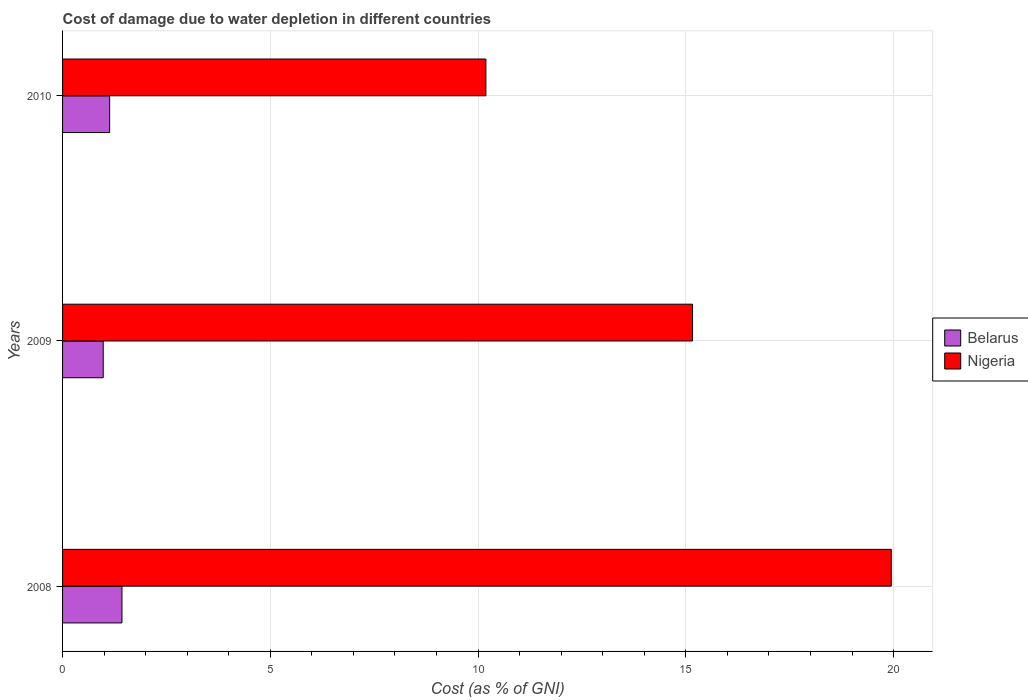How many different coloured bars are there?
Offer a terse response. 2. Are the number of bars on each tick of the Y-axis equal?
Your answer should be compact. Yes. How many bars are there on the 2nd tick from the bottom?
Provide a short and direct response. 2. In how many cases, is the number of bars for a given year not equal to the number of legend labels?
Your response must be concise. 0. What is the cost of damage caused due to water depletion in Nigeria in 2008?
Provide a succinct answer. 19.94. Across all years, what is the maximum cost of damage caused due to water depletion in Nigeria?
Give a very brief answer. 19.94. Across all years, what is the minimum cost of damage caused due to water depletion in Belarus?
Your answer should be compact. 0.98. In which year was the cost of damage caused due to water depletion in Belarus maximum?
Provide a short and direct response. 2008. What is the total cost of damage caused due to water depletion in Belarus in the graph?
Your answer should be compact. 3.54. What is the difference between the cost of damage caused due to water depletion in Nigeria in 2009 and that in 2010?
Your answer should be very brief. 4.97. What is the difference between the cost of damage caused due to water depletion in Nigeria in 2010 and the cost of damage caused due to water depletion in Belarus in 2008?
Ensure brevity in your answer.  8.76. What is the average cost of damage caused due to water depletion in Belarus per year?
Offer a terse response. 1.18. In the year 2009, what is the difference between the cost of damage caused due to water depletion in Nigeria and cost of damage caused due to water depletion in Belarus?
Your response must be concise. 14.18. What is the ratio of the cost of damage caused due to water depletion in Belarus in 2009 to that in 2010?
Your response must be concise. 0.86. What is the difference between the highest and the second highest cost of damage caused due to water depletion in Nigeria?
Give a very brief answer. 4.78. What is the difference between the highest and the lowest cost of damage caused due to water depletion in Nigeria?
Provide a succinct answer. 9.76. What does the 2nd bar from the top in 2009 represents?
Keep it short and to the point. Belarus. What does the 2nd bar from the bottom in 2008 represents?
Ensure brevity in your answer.  Nigeria. How many bars are there?
Offer a terse response. 6. Are all the bars in the graph horizontal?
Your answer should be very brief. Yes. How many years are there in the graph?
Provide a short and direct response. 3. What is the difference between two consecutive major ticks on the X-axis?
Give a very brief answer. 5. Are the values on the major ticks of X-axis written in scientific E-notation?
Offer a terse response. No. Does the graph contain any zero values?
Your answer should be very brief. No. How are the legend labels stacked?
Your response must be concise. Vertical. What is the title of the graph?
Keep it short and to the point. Cost of damage due to water depletion in different countries. Does "Pacific island small states" appear as one of the legend labels in the graph?
Your answer should be compact. No. What is the label or title of the X-axis?
Keep it short and to the point. Cost (as % of GNI). What is the label or title of the Y-axis?
Ensure brevity in your answer.  Years. What is the Cost (as % of GNI) of Belarus in 2008?
Offer a terse response. 1.43. What is the Cost (as % of GNI) in Nigeria in 2008?
Keep it short and to the point. 19.94. What is the Cost (as % of GNI) in Belarus in 2009?
Give a very brief answer. 0.98. What is the Cost (as % of GNI) in Nigeria in 2009?
Make the answer very short. 15.16. What is the Cost (as % of GNI) of Belarus in 2010?
Make the answer very short. 1.13. What is the Cost (as % of GNI) of Nigeria in 2010?
Provide a short and direct response. 10.19. Across all years, what is the maximum Cost (as % of GNI) in Belarus?
Make the answer very short. 1.43. Across all years, what is the maximum Cost (as % of GNI) in Nigeria?
Your response must be concise. 19.94. Across all years, what is the minimum Cost (as % of GNI) of Belarus?
Your answer should be very brief. 0.98. Across all years, what is the minimum Cost (as % of GNI) in Nigeria?
Keep it short and to the point. 10.19. What is the total Cost (as % of GNI) of Belarus in the graph?
Provide a succinct answer. 3.54. What is the total Cost (as % of GNI) in Nigeria in the graph?
Ensure brevity in your answer.  45.29. What is the difference between the Cost (as % of GNI) of Belarus in 2008 and that in 2009?
Keep it short and to the point. 0.45. What is the difference between the Cost (as % of GNI) in Nigeria in 2008 and that in 2009?
Offer a very short reply. 4.78. What is the difference between the Cost (as % of GNI) of Belarus in 2008 and that in 2010?
Provide a short and direct response. 0.3. What is the difference between the Cost (as % of GNI) of Nigeria in 2008 and that in 2010?
Offer a terse response. 9.76. What is the difference between the Cost (as % of GNI) of Belarus in 2009 and that in 2010?
Offer a terse response. -0.15. What is the difference between the Cost (as % of GNI) of Nigeria in 2009 and that in 2010?
Offer a very short reply. 4.97. What is the difference between the Cost (as % of GNI) of Belarus in 2008 and the Cost (as % of GNI) of Nigeria in 2009?
Provide a short and direct response. -13.73. What is the difference between the Cost (as % of GNI) of Belarus in 2008 and the Cost (as % of GNI) of Nigeria in 2010?
Your answer should be compact. -8.76. What is the difference between the Cost (as % of GNI) of Belarus in 2009 and the Cost (as % of GNI) of Nigeria in 2010?
Keep it short and to the point. -9.21. What is the average Cost (as % of GNI) of Belarus per year?
Offer a terse response. 1.18. What is the average Cost (as % of GNI) in Nigeria per year?
Provide a succinct answer. 15.1. In the year 2008, what is the difference between the Cost (as % of GNI) of Belarus and Cost (as % of GNI) of Nigeria?
Offer a terse response. -18.51. In the year 2009, what is the difference between the Cost (as % of GNI) of Belarus and Cost (as % of GNI) of Nigeria?
Make the answer very short. -14.18. In the year 2010, what is the difference between the Cost (as % of GNI) in Belarus and Cost (as % of GNI) in Nigeria?
Provide a short and direct response. -9.05. What is the ratio of the Cost (as % of GNI) in Belarus in 2008 to that in 2009?
Make the answer very short. 1.46. What is the ratio of the Cost (as % of GNI) in Nigeria in 2008 to that in 2009?
Offer a very short reply. 1.32. What is the ratio of the Cost (as % of GNI) of Belarus in 2008 to that in 2010?
Keep it short and to the point. 1.26. What is the ratio of the Cost (as % of GNI) in Nigeria in 2008 to that in 2010?
Offer a very short reply. 1.96. What is the ratio of the Cost (as % of GNI) of Belarus in 2009 to that in 2010?
Give a very brief answer. 0.86. What is the ratio of the Cost (as % of GNI) of Nigeria in 2009 to that in 2010?
Your answer should be compact. 1.49. What is the difference between the highest and the second highest Cost (as % of GNI) in Belarus?
Ensure brevity in your answer.  0.3. What is the difference between the highest and the second highest Cost (as % of GNI) of Nigeria?
Offer a very short reply. 4.78. What is the difference between the highest and the lowest Cost (as % of GNI) of Belarus?
Give a very brief answer. 0.45. What is the difference between the highest and the lowest Cost (as % of GNI) in Nigeria?
Your answer should be compact. 9.76. 